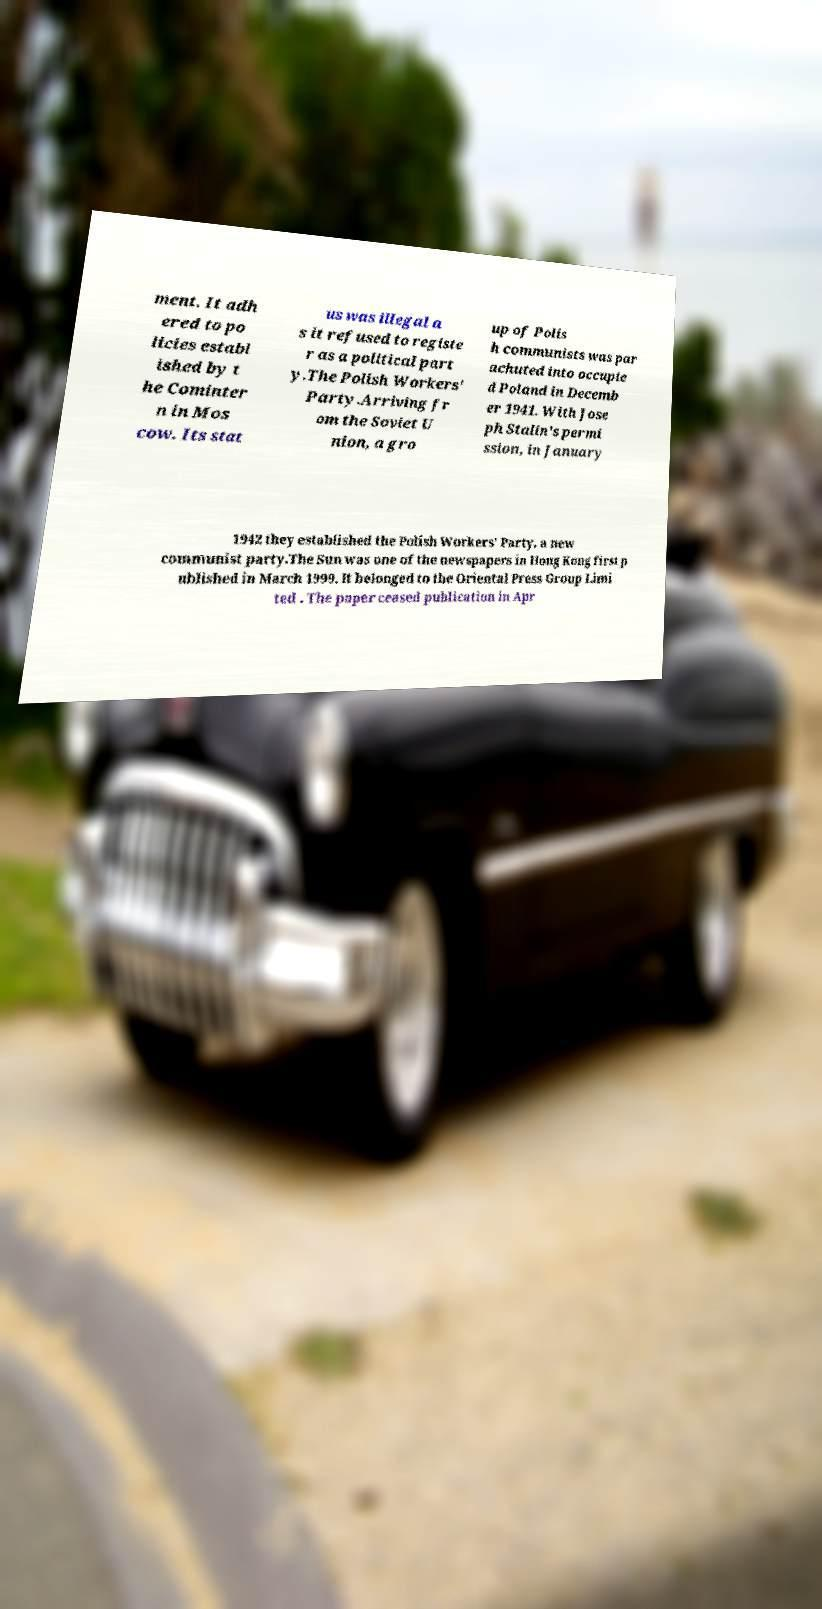I need the written content from this picture converted into text. Can you do that? ment. It adh ered to po licies establ ished by t he Cominter n in Mos cow. Its stat us was illegal a s it refused to registe r as a political part y.The Polish Workers' Party.Arriving fr om the Soviet U nion, a gro up of Polis h communists was par achuted into occupie d Poland in Decemb er 1941. With Jose ph Stalin's permi ssion, in January 1942 they established the Polish Workers' Party, a new communist party.The Sun was one of the newspapers in Hong Kong first p ublished in March 1999. It belonged to the Oriental Press Group Limi ted . The paper ceased publication in Apr 